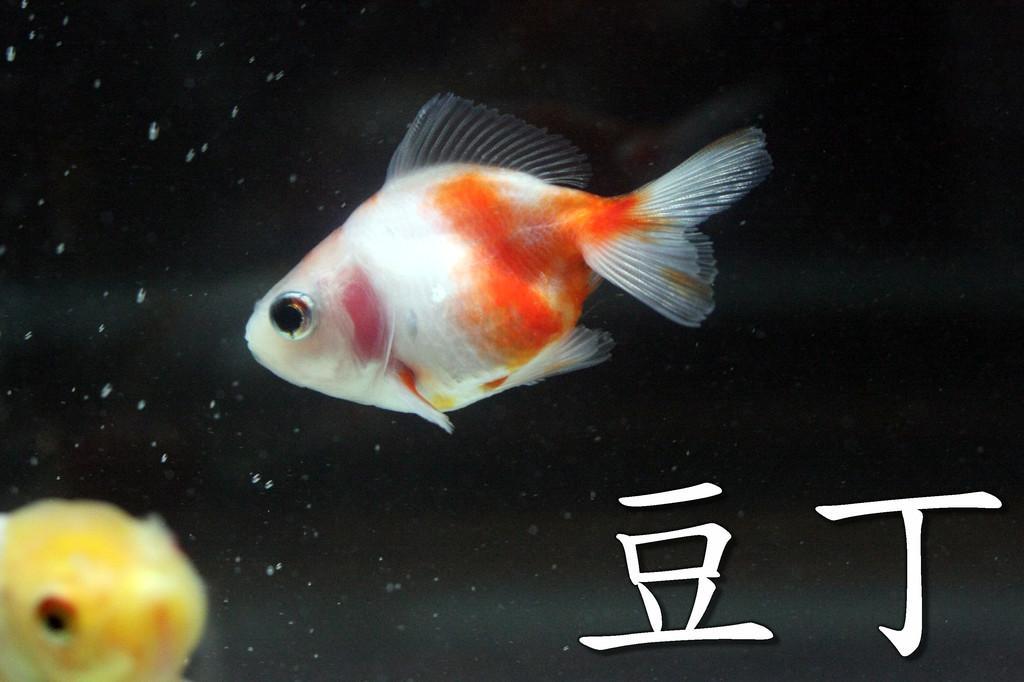Please provide a concise description of this image. There is a fish which is in white and orange color and there is another fish which is in yellow color in the left corner and there is something written in the right corner. 